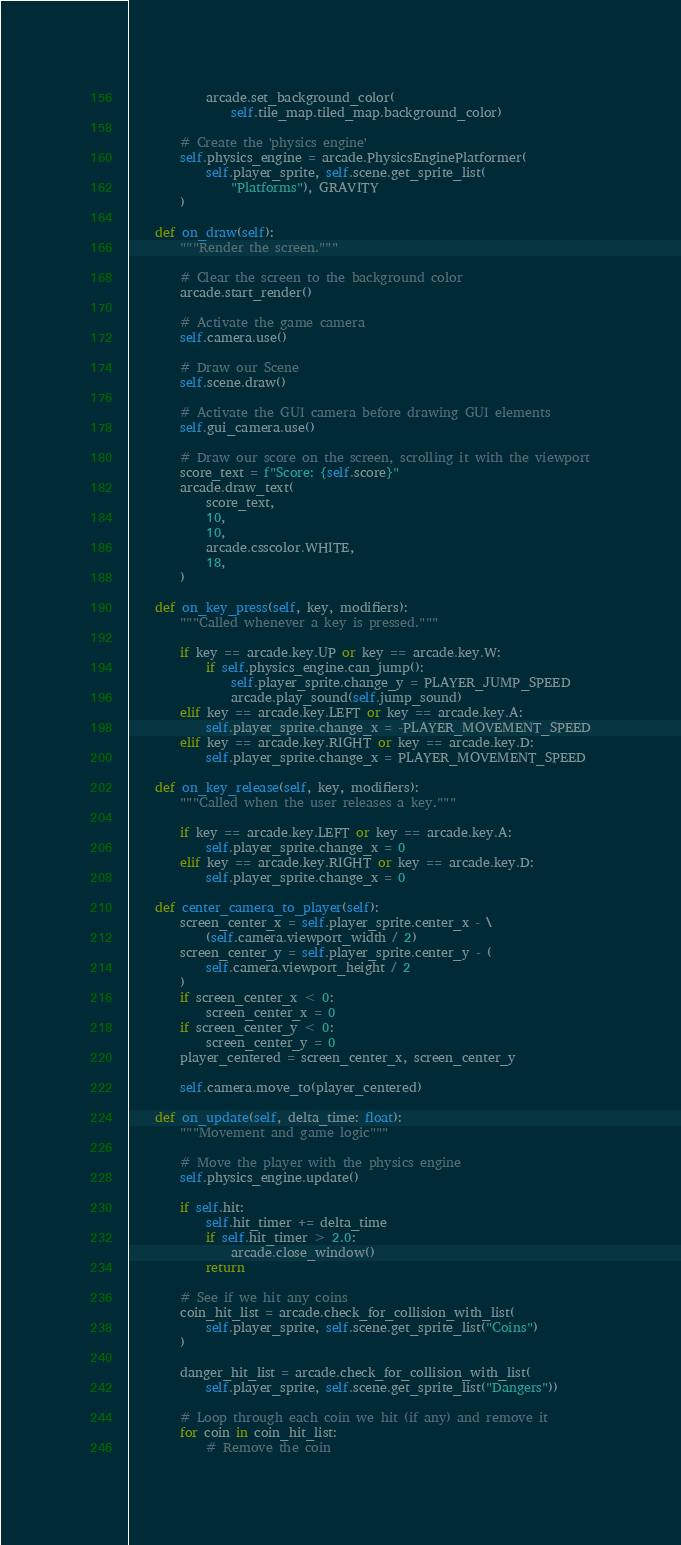Convert code to text. <code><loc_0><loc_0><loc_500><loc_500><_Python_>            arcade.set_background_color(
                self.tile_map.tiled_map.background_color)

        # Create the 'physics engine'
        self.physics_engine = arcade.PhysicsEnginePlatformer(
            self.player_sprite, self.scene.get_sprite_list(
                "Platforms"), GRAVITY
        )

    def on_draw(self):
        """Render the screen."""

        # Clear the screen to the background color
        arcade.start_render()

        # Activate the game camera
        self.camera.use()

        # Draw our Scene
        self.scene.draw()

        # Activate the GUI camera before drawing GUI elements
        self.gui_camera.use()

        # Draw our score on the screen, scrolling it with the viewport
        score_text = f"Score: {self.score}"
        arcade.draw_text(
            score_text,
            10,
            10,
            arcade.csscolor.WHITE,
            18,
        )

    def on_key_press(self, key, modifiers):
        """Called whenever a key is pressed."""

        if key == arcade.key.UP or key == arcade.key.W:
            if self.physics_engine.can_jump():
                self.player_sprite.change_y = PLAYER_JUMP_SPEED
                arcade.play_sound(self.jump_sound)
        elif key == arcade.key.LEFT or key == arcade.key.A:
            self.player_sprite.change_x = -PLAYER_MOVEMENT_SPEED
        elif key == arcade.key.RIGHT or key == arcade.key.D:
            self.player_sprite.change_x = PLAYER_MOVEMENT_SPEED

    def on_key_release(self, key, modifiers):
        """Called when the user releases a key."""

        if key == arcade.key.LEFT or key == arcade.key.A:
            self.player_sprite.change_x = 0
        elif key == arcade.key.RIGHT or key == arcade.key.D:
            self.player_sprite.change_x = 0

    def center_camera_to_player(self):
        screen_center_x = self.player_sprite.center_x - \
            (self.camera.viewport_width / 2)
        screen_center_y = self.player_sprite.center_y - (
            self.camera.viewport_height / 2
        )
        if screen_center_x < 0:
            screen_center_x = 0
        if screen_center_y < 0:
            screen_center_y = 0
        player_centered = screen_center_x, screen_center_y

        self.camera.move_to(player_centered)

    def on_update(self, delta_time: float):
        """Movement and game logic"""

        # Move the player with the physics engine
        self.physics_engine.update()

        if self.hit:
            self.hit_timer += delta_time
            if self.hit_timer > 2.0:
                arcade.close_window()
            return

        # See if we hit any coins
        coin_hit_list = arcade.check_for_collision_with_list(
            self.player_sprite, self.scene.get_sprite_list("Coins")
        )

        danger_hit_list = arcade.check_for_collision_with_list(
            self.player_sprite, self.scene.get_sprite_list("Dangers"))

        # Loop through each coin we hit (if any) and remove it
        for coin in coin_hit_list:
            # Remove the coin</code> 